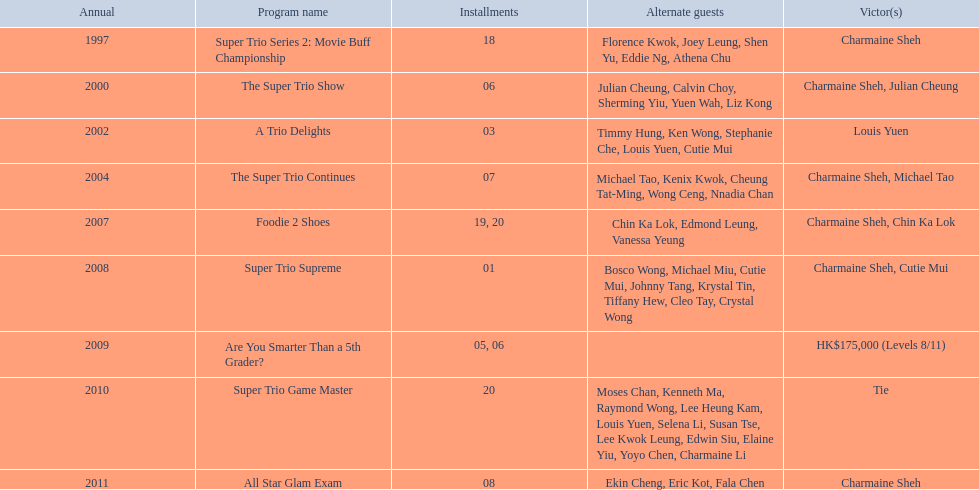What is the number of episodes charmaine sheh appeared in the variety show super trio 2: movie buff champions? 18. 